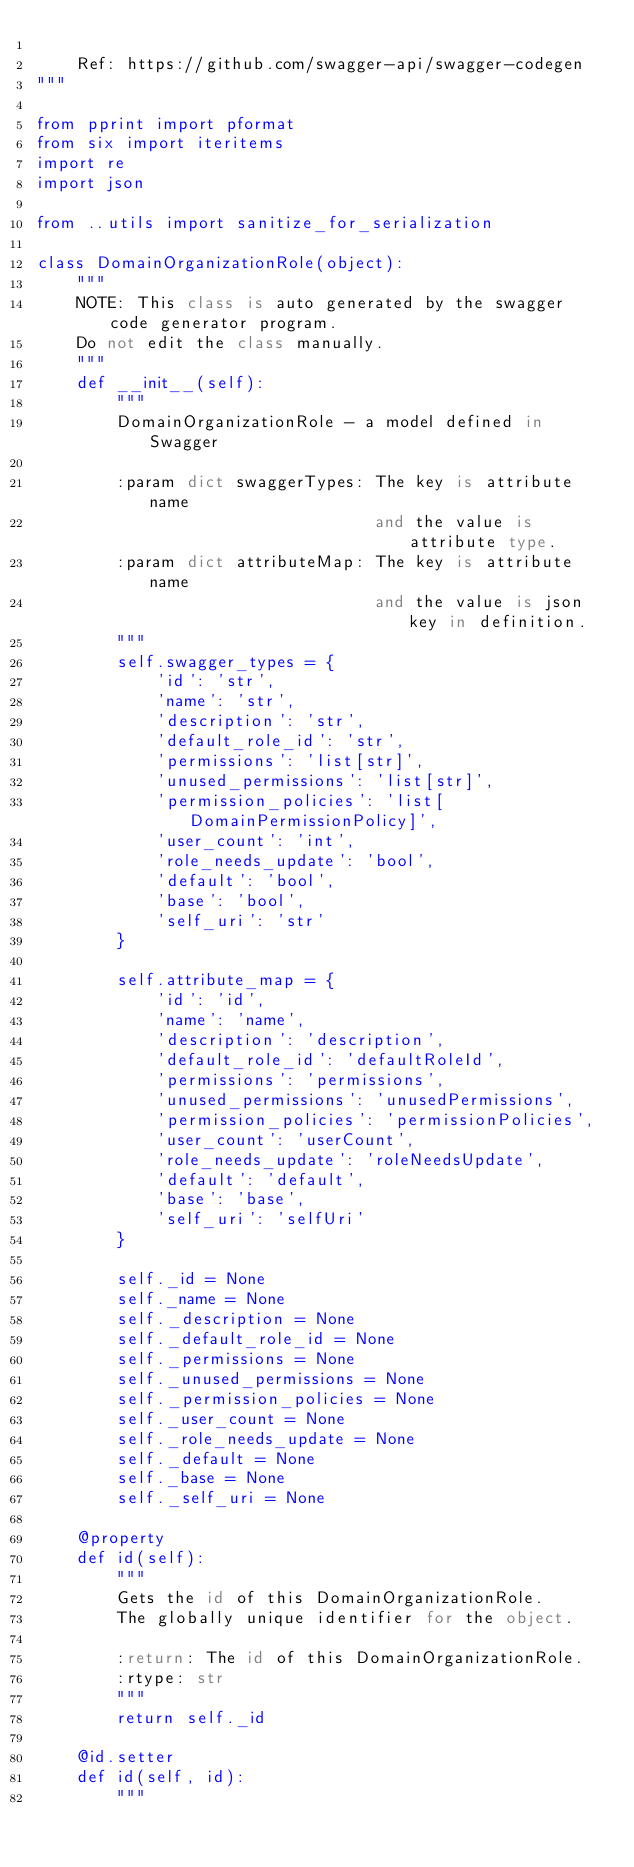Convert code to text. <code><loc_0><loc_0><loc_500><loc_500><_Python_>
    Ref: https://github.com/swagger-api/swagger-codegen
"""

from pprint import pformat
from six import iteritems
import re
import json

from ..utils import sanitize_for_serialization

class DomainOrganizationRole(object):
    """
    NOTE: This class is auto generated by the swagger code generator program.
    Do not edit the class manually.
    """
    def __init__(self):
        """
        DomainOrganizationRole - a model defined in Swagger

        :param dict swaggerTypes: The key is attribute name
                                  and the value is attribute type.
        :param dict attributeMap: The key is attribute name
                                  and the value is json key in definition.
        """
        self.swagger_types = {
            'id': 'str',
            'name': 'str',
            'description': 'str',
            'default_role_id': 'str',
            'permissions': 'list[str]',
            'unused_permissions': 'list[str]',
            'permission_policies': 'list[DomainPermissionPolicy]',
            'user_count': 'int',
            'role_needs_update': 'bool',
            'default': 'bool',
            'base': 'bool',
            'self_uri': 'str'
        }

        self.attribute_map = {
            'id': 'id',
            'name': 'name',
            'description': 'description',
            'default_role_id': 'defaultRoleId',
            'permissions': 'permissions',
            'unused_permissions': 'unusedPermissions',
            'permission_policies': 'permissionPolicies',
            'user_count': 'userCount',
            'role_needs_update': 'roleNeedsUpdate',
            'default': 'default',
            'base': 'base',
            'self_uri': 'selfUri'
        }

        self._id = None
        self._name = None
        self._description = None
        self._default_role_id = None
        self._permissions = None
        self._unused_permissions = None
        self._permission_policies = None
        self._user_count = None
        self._role_needs_update = None
        self._default = None
        self._base = None
        self._self_uri = None

    @property
    def id(self):
        """
        Gets the id of this DomainOrganizationRole.
        The globally unique identifier for the object.

        :return: The id of this DomainOrganizationRole.
        :rtype: str
        """
        return self._id

    @id.setter
    def id(self, id):
        """</code> 